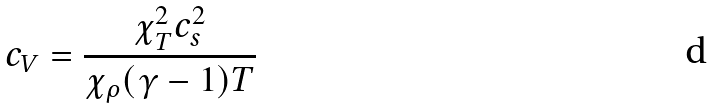<formula> <loc_0><loc_0><loc_500><loc_500>c _ { V } = \frac { \chi _ { T } ^ { 2 } c _ { s } ^ { 2 } } { \chi _ { \rho } ( \gamma - 1 ) T }</formula> 